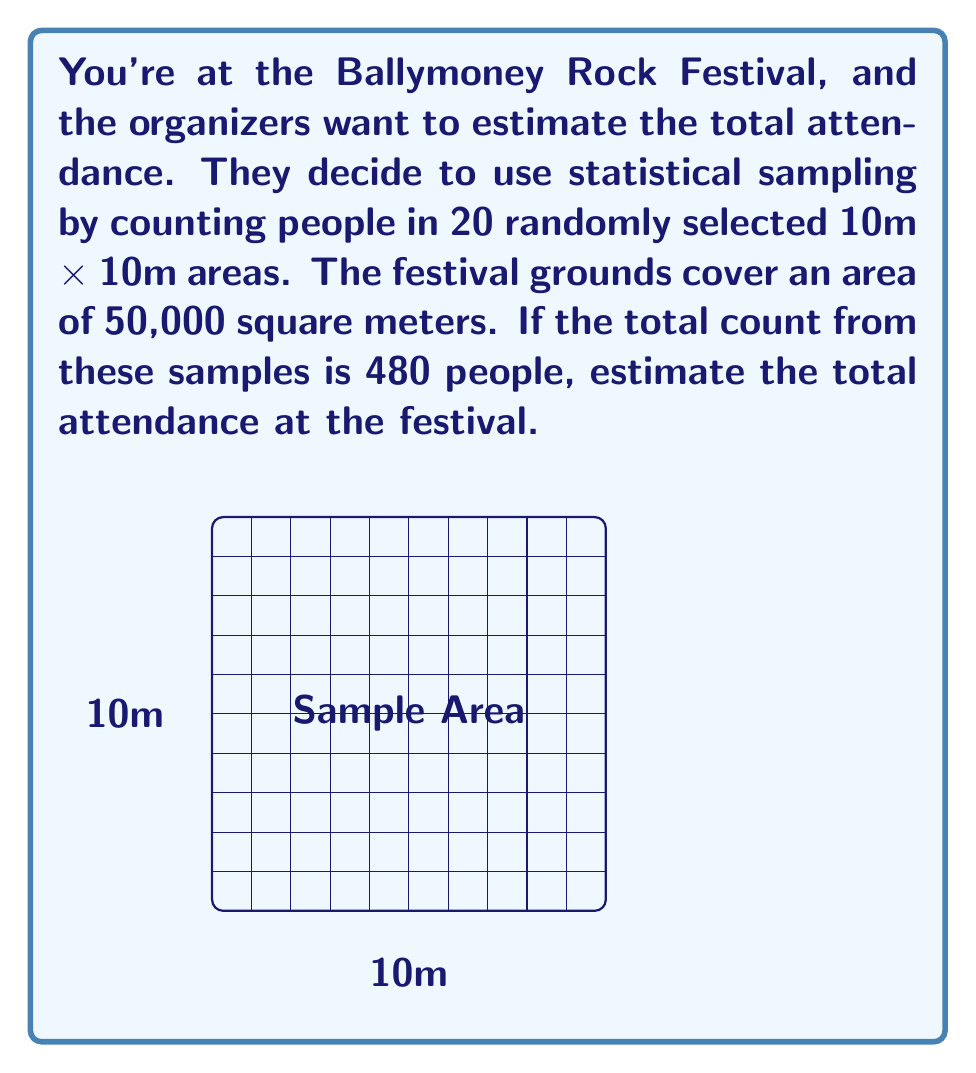Provide a solution to this math problem. Let's approach this step-by-step:

1) First, we need to calculate the area of each sample:
   Area of each sample = $10\textrm{m} \times 10\textrm{m} = 100\textrm{m}^2$

2) Now, let's find how many such samples would fit in the entire festival area:
   Number of samples in total area = $\frac{\text{Total area}}{\text{Sample area}} = \frac{50,000\textrm{m}^2}{100\textrm{m}^2} = 500$

3) We know that in 20 samples, there were 480 people. Let's find the average number of people per sample:
   Average people per sample = $\frac{480\textrm{ people}}{20\textrm{ samples}} = 24\textrm{ people/sample}$

4) Now, we can estimate the total attendance by multiplying this average by the total number of samples:
   Estimated total attendance = $24\textrm{ people/sample} \times 500\textrm{ samples} = 12,000\textrm{ people}$

This method assumes that the distribution of people across the festival grounds is relatively uniform, which may not always be the case in real-life scenarios. However, it provides a reasonable estimate based on the given data.
Answer: 12,000 people 